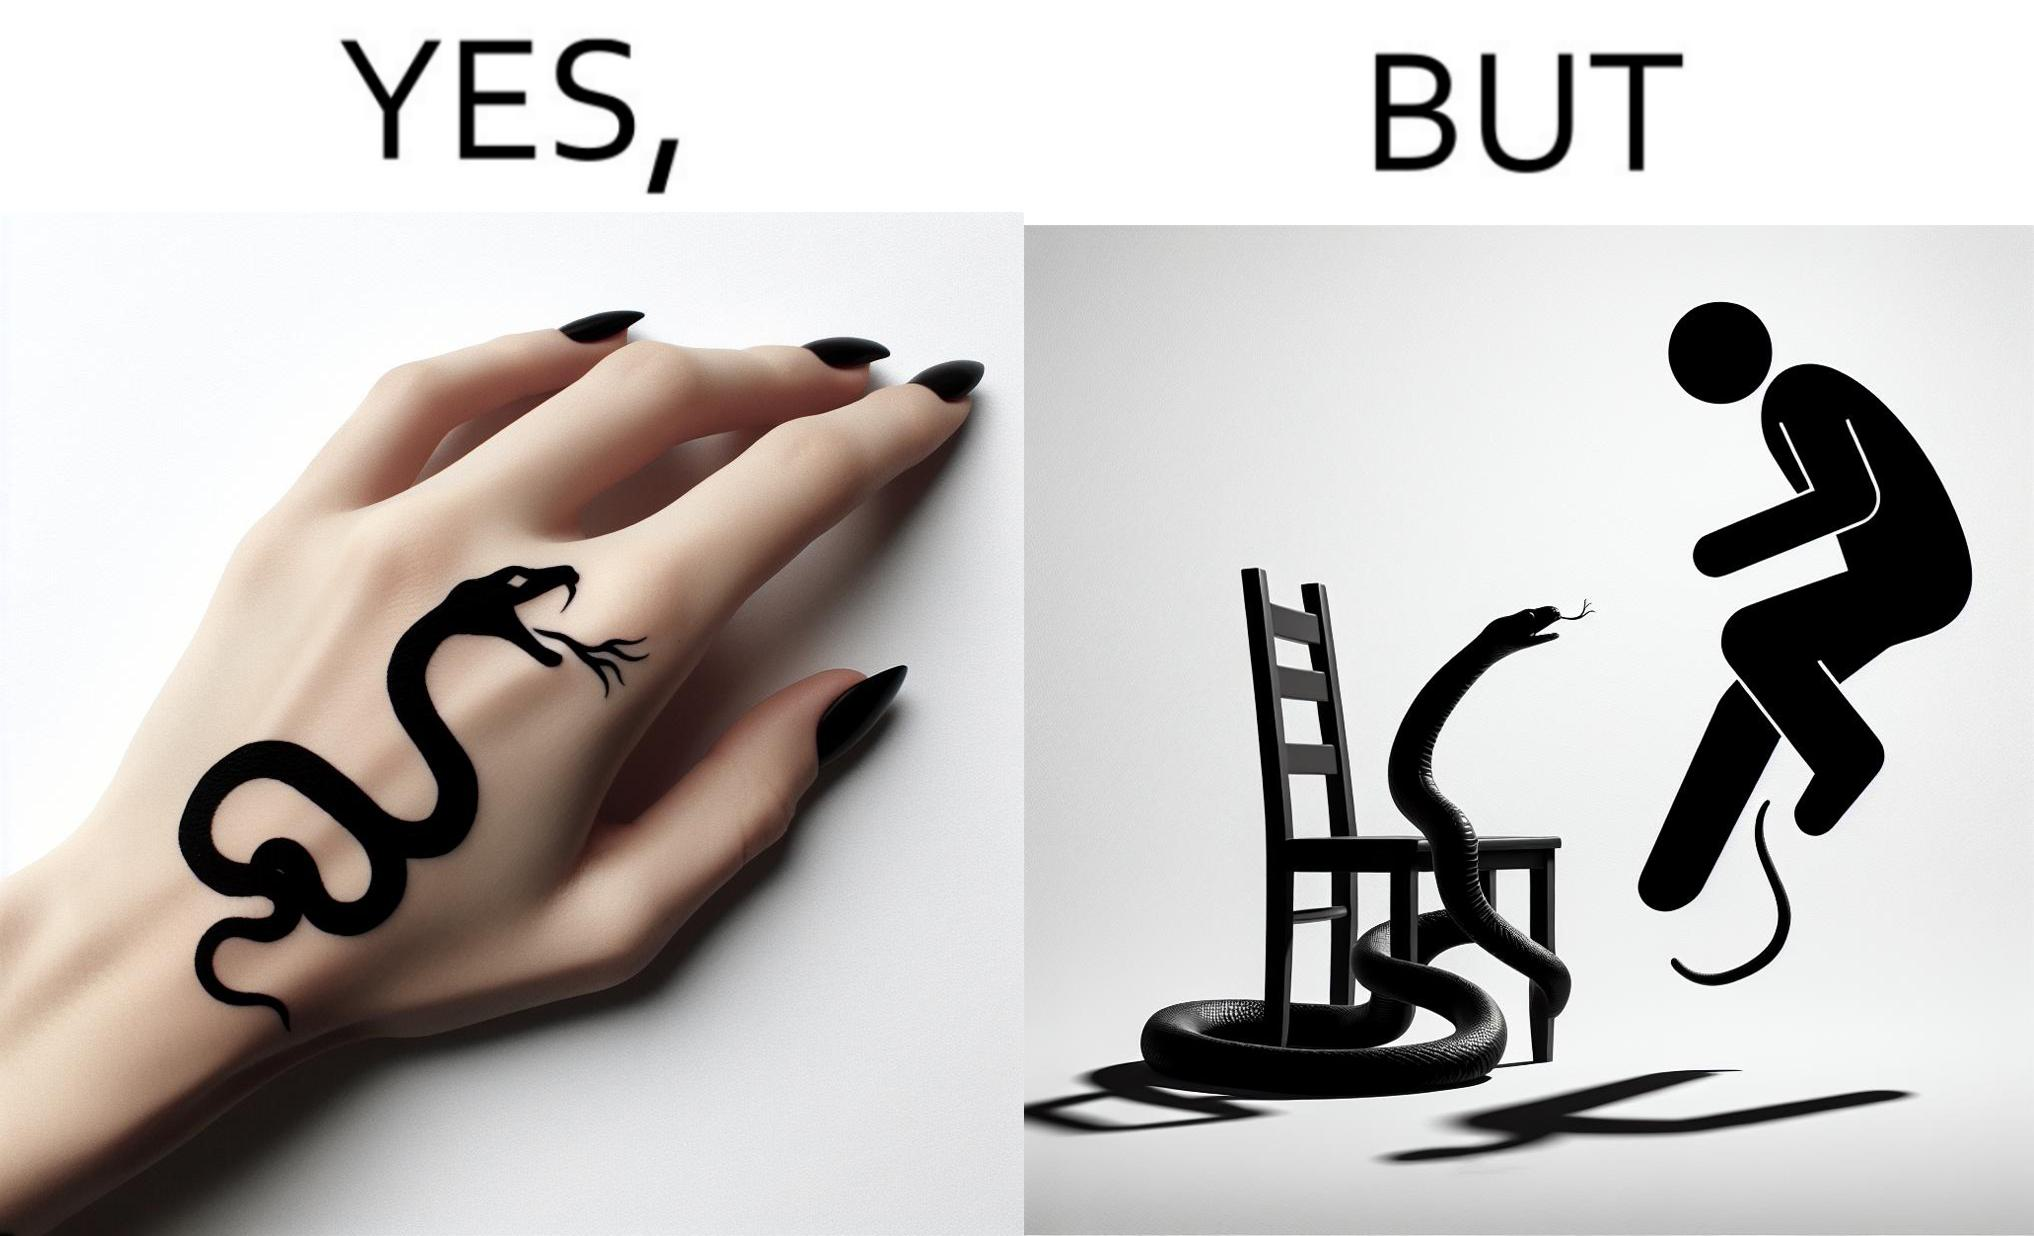Describe what you see in this image. The image is ironic, because in the first image the tattoo of a snake on someone's hand may give us a hint about how powerful or brave the person can be who is having this tattoo but in the second image the person with same tattoo is seen frightened due to a snake in his house 